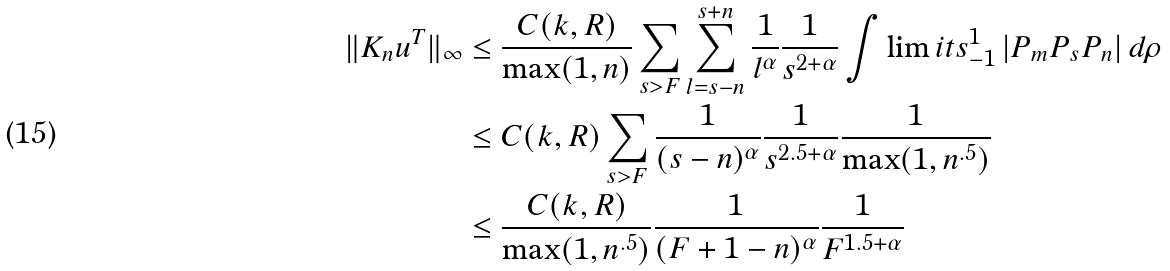Convert formula to latex. <formula><loc_0><loc_0><loc_500><loc_500>\| K _ { n } u ^ { T } \| _ { \infty } & \leq \frac { C ( k , R ) } { \max ( 1 , n ) } \sum _ { s > F } \sum _ { l = s - n } ^ { s + n } \frac { 1 } { l ^ { \alpha } } \frac { 1 } { s ^ { 2 + \alpha } } \int \lim i t s _ { - 1 } ^ { 1 } \, | P _ { m } P _ { s } P _ { n } | \, d \rho \\ & \leq C ( k , R ) \sum _ { s > F } \frac { 1 } { ( s - n ) ^ { \alpha } } \frac { 1 } { s ^ { 2 . 5 + \alpha } } \frac { 1 } { \max ( 1 , n ^ { . 5 } ) } \\ & \leq \frac { C ( k , R ) } { \max ( 1 , n ^ { . 5 } ) } \frac { 1 } { ( F + 1 - n ) ^ { \alpha } } \frac { 1 } { F ^ { 1 . 5 + \alpha } } \\</formula> 